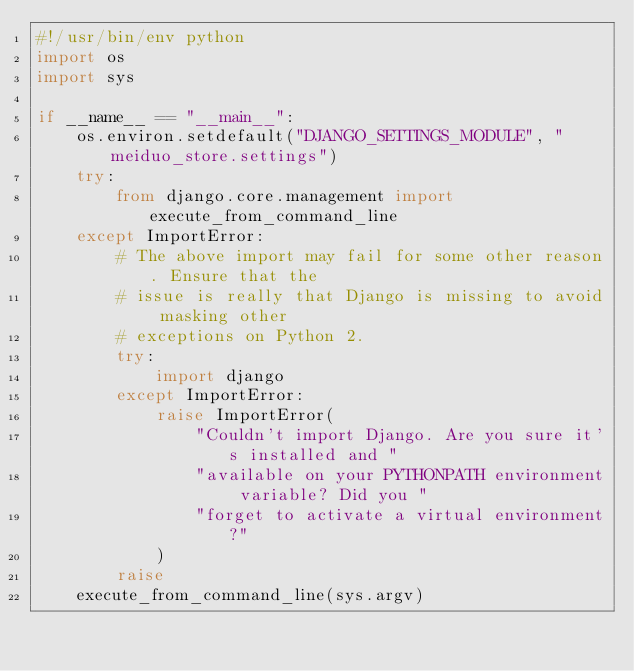Convert code to text. <code><loc_0><loc_0><loc_500><loc_500><_Python_>#!/usr/bin/env python
import os
import sys

if __name__ == "__main__":
    os.environ.setdefault("DJANGO_SETTINGS_MODULE", "meiduo_store.settings")
    try:
        from django.core.management import execute_from_command_line
    except ImportError:
        # The above import may fail for some other reason. Ensure that the
        # issue is really that Django is missing to avoid masking other
        # exceptions on Python 2.
        try:
            import django
        except ImportError:
            raise ImportError(
                "Couldn't import Django. Are you sure it's installed and "
                "available on your PYTHONPATH environment variable? Did you "
                "forget to activate a virtual environment?"
            )
        raise
    execute_from_command_line(sys.argv)
</code> 